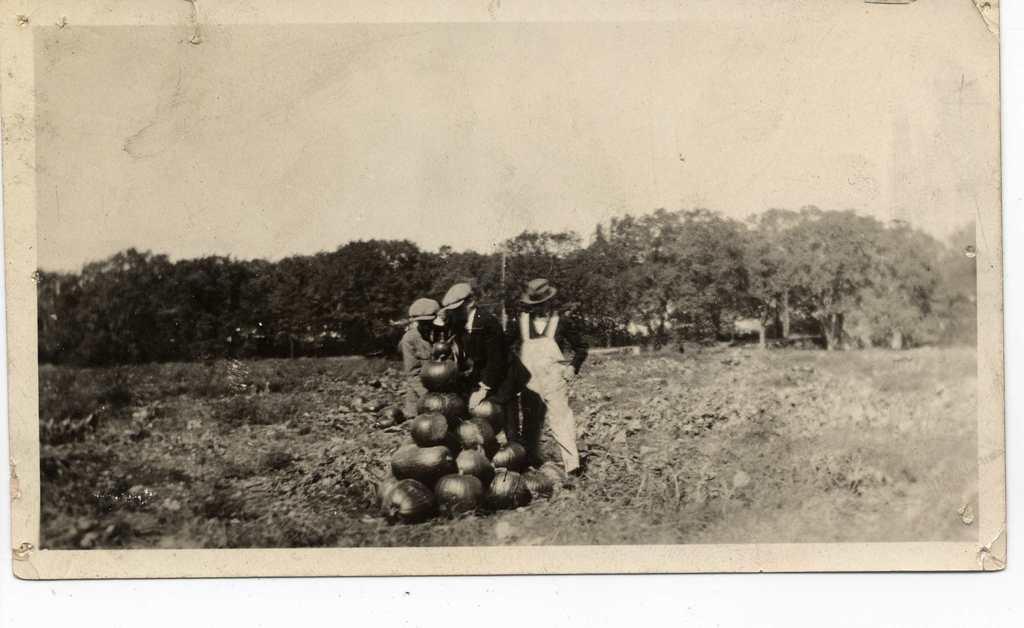What is the color scheme of the image? The image is black and white. What can be seen in the foreground of the image? There are pumpkins and people in the foreground of the image. What type of vegetation is present in the image? There are plants in the image. What is visible in the background of the image? There are trees and the sky in the background of the image. What type of flowers does the queen hold in her hand in the image? There is no queen or flowers present in the image. How many passengers are visible in the image? There are no passengers visible in the image; it features pumpkins and people. 